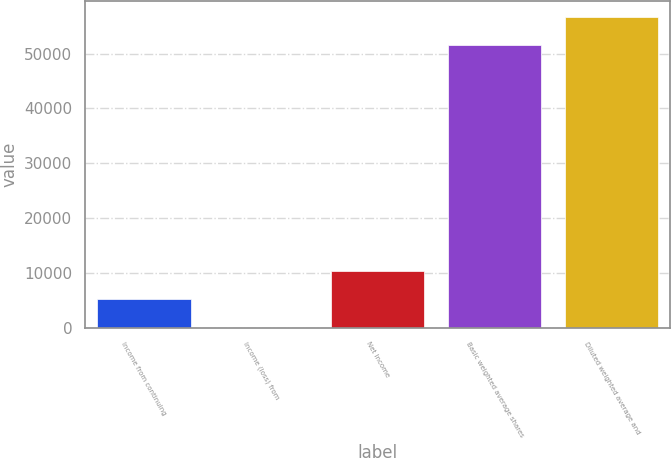Convert chart. <chart><loc_0><loc_0><loc_500><loc_500><bar_chart><fcel>Income from continuing<fcel>Income (loss) from<fcel>Net Income<fcel>Basic weighted average shares<fcel>Diluted weighted average and<nl><fcel>5184.32<fcel>0.02<fcel>10368.6<fcel>51566<fcel>56750.3<nl></chart> 